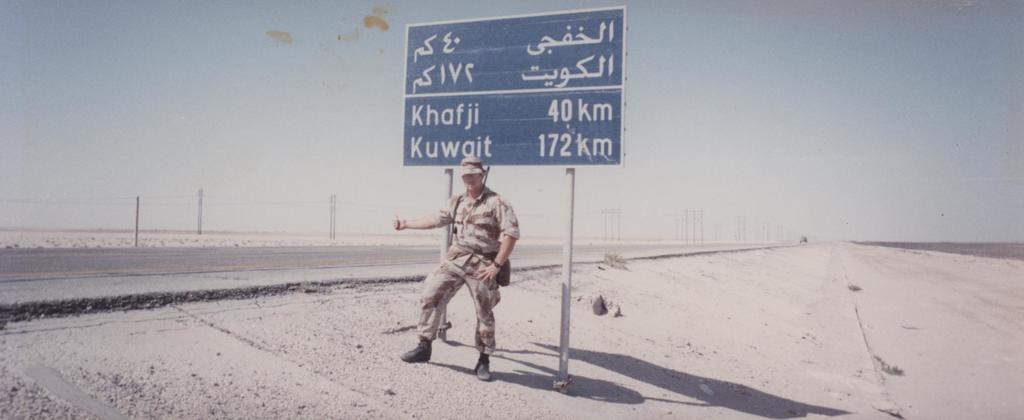How many kilometers till khafji?
Your answer should be very brief. 40. How many kilometers until kuwait?
Give a very brief answer. 172. 